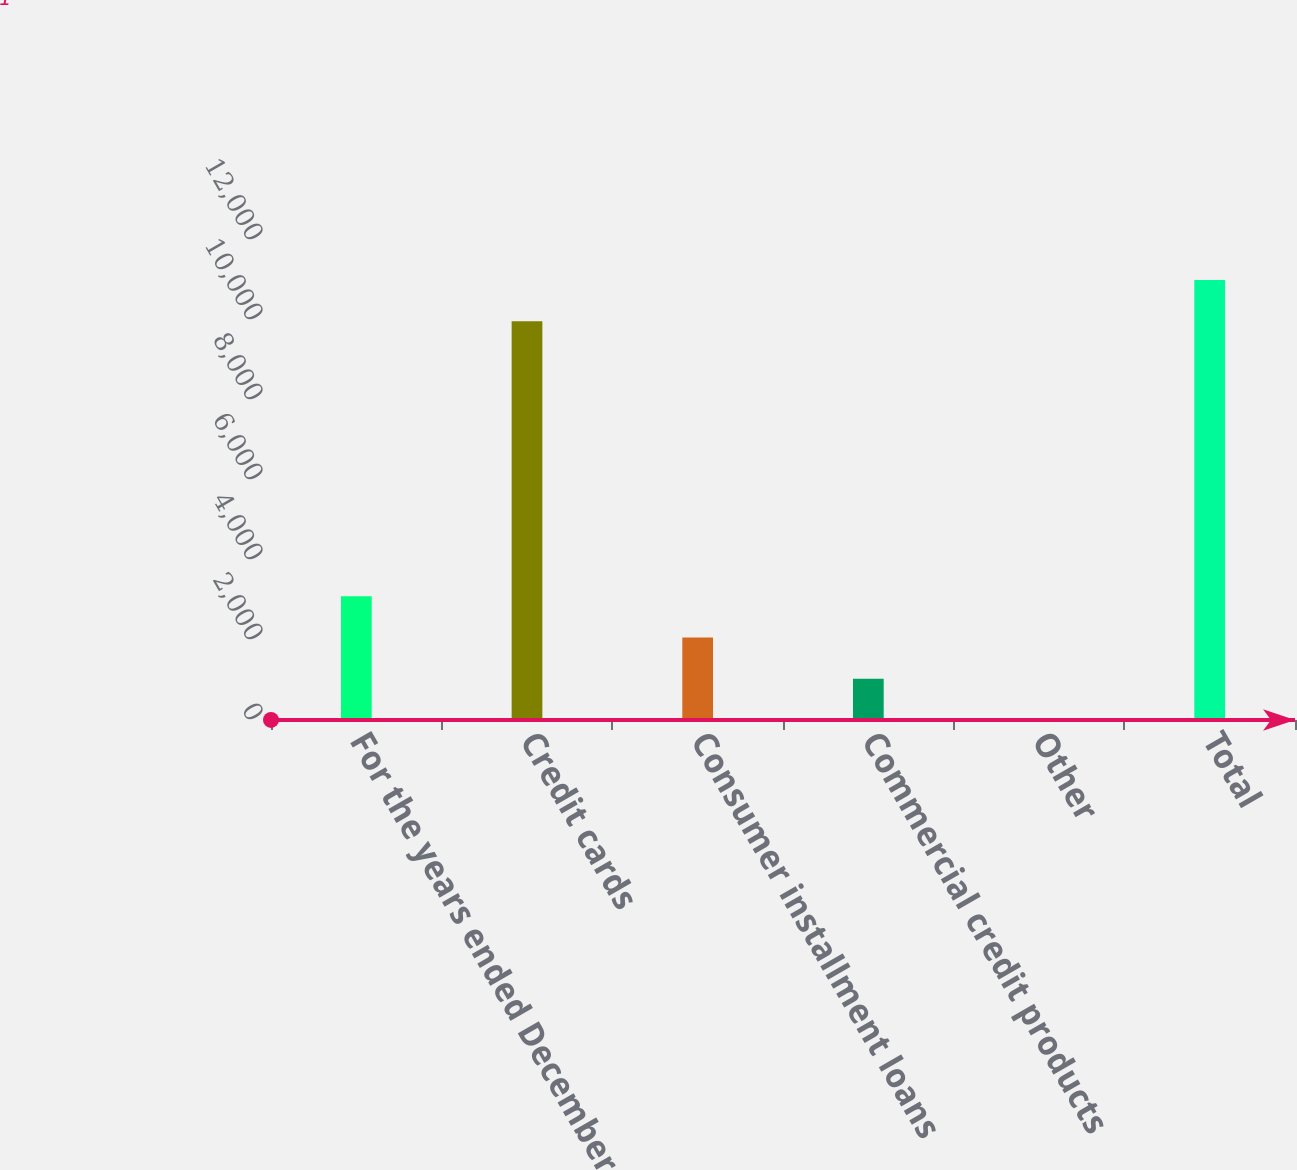Convert chart to OTSL. <chart><loc_0><loc_0><loc_500><loc_500><bar_chart><fcel>For the years ended December<fcel>Credit cards<fcel>Consumer installment loans<fcel>Commercial credit products<fcel>Other<fcel>Total<nl><fcel>3090.7<fcel>9967<fcel>2060.8<fcel>1030.9<fcel>1<fcel>10996.9<nl></chart> 